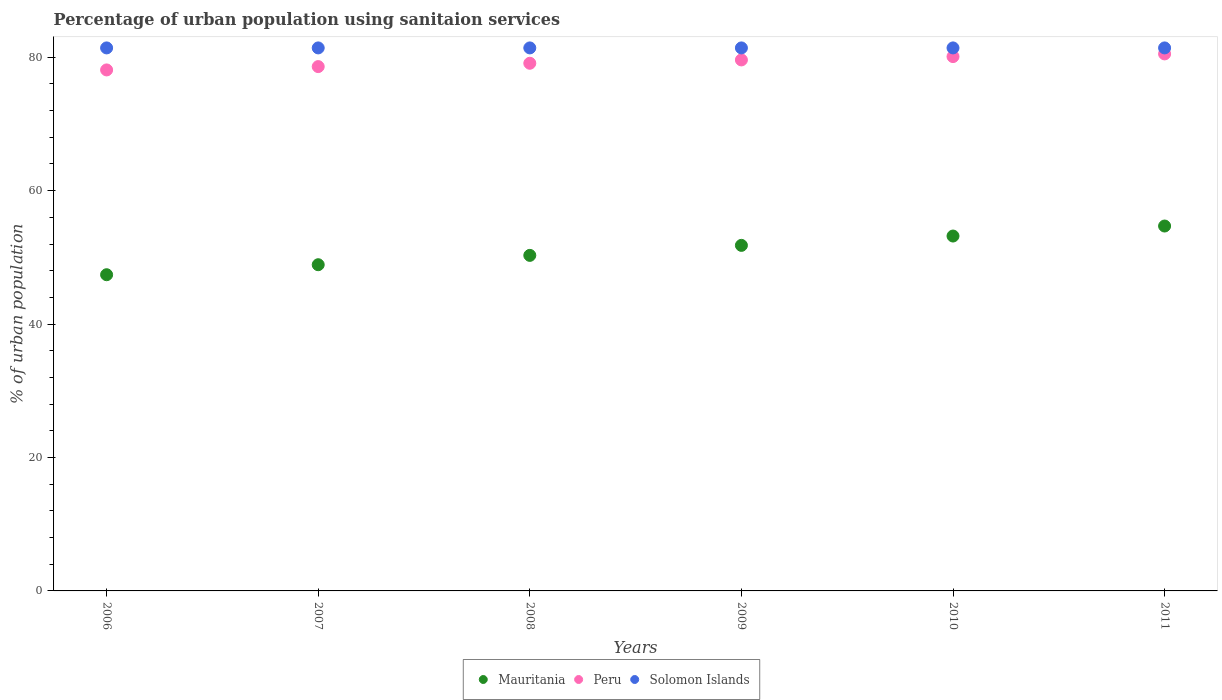Is the number of dotlines equal to the number of legend labels?
Your response must be concise. Yes. What is the percentage of urban population using sanitaion services in Mauritania in 2011?
Your response must be concise. 54.7. Across all years, what is the maximum percentage of urban population using sanitaion services in Mauritania?
Offer a very short reply. 54.7. Across all years, what is the minimum percentage of urban population using sanitaion services in Solomon Islands?
Give a very brief answer. 81.4. In which year was the percentage of urban population using sanitaion services in Mauritania minimum?
Your response must be concise. 2006. What is the total percentage of urban population using sanitaion services in Mauritania in the graph?
Provide a short and direct response. 306.3. What is the difference between the percentage of urban population using sanitaion services in Solomon Islands in 2008 and that in 2010?
Your answer should be very brief. 0. What is the difference between the percentage of urban population using sanitaion services in Solomon Islands in 2009 and the percentage of urban population using sanitaion services in Peru in 2008?
Your response must be concise. 2.3. What is the average percentage of urban population using sanitaion services in Peru per year?
Your answer should be very brief. 79.33. In the year 2010, what is the difference between the percentage of urban population using sanitaion services in Mauritania and percentage of urban population using sanitaion services in Solomon Islands?
Your answer should be compact. -28.2. Is the percentage of urban population using sanitaion services in Peru in 2008 less than that in 2010?
Keep it short and to the point. Yes. Is the difference between the percentage of urban population using sanitaion services in Mauritania in 2006 and 2008 greater than the difference between the percentage of urban population using sanitaion services in Solomon Islands in 2006 and 2008?
Your answer should be compact. No. What is the difference between the highest and the second highest percentage of urban population using sanitaion services in Mauritania?
Keep it short and to the point. 1.5. What is the difference between the highest and the lowest percentage of urban population using sanitaion services in Peru?
Your response must be concise. 2.4. Is the sum of the percentage of urban population using sanitaion services in Peru in 2006 and 2011 greater than the maximum percentage of urban population using sanitaion services in Mauritania across all years?
Provide a succinct answer. Yes. Is the percentage of urban population using sanitaion services in Solomon Islands strictly less than the percentage of urban population using sanitaion services in Peru over the years?
Your answer should be very brief. No. Are the values on the major ticks of Y-axis written in scientific E-notation?
Give a very brief answer. No. Does the graph contain grids?
Give a very brief answer. No. What is the title of the graph?
Keep it short and to the point. Percentage of urban population using sanitaion services. What is the label or title of the Y-axis?
Your answer should be very brief. % of urban population. What is the % of urban population of Mauritania in 2006?
Provide a short and direct response. 47.4. What is the % of urban population of Peru in 2006?
Ensure brevity in your answer.  78.1. What is the % of urban population of Solomon Islands in 2006?
Provide a succinct answer. 81.4. What is the % of urban population of Mauritania in 2007?
Your answer should be very brief. 48.9. What is the % of urban population in Peru in 2007?
Offer a terse response. 78.6. What is the % of urban population in Solomon Islands in 2007?
Give a very brief answer. 81.4. What is the % of urban population in Mauritania in 2008?
Your answer should be compact. 50.3. What is the % of urban population of Peru in 2008?
Your response must be concise. 79.1. What is the % of urban population in Solomon Islands in 2008?
Keep it short and to the point. 81.4. What is the % of urban population of Mauritania in 2009?
Provide a succinct answer. 51.8. What is the % of urban population of Peru in 2009?
Ensure brevity in your answer.  79.6. What is the % of urban population of Solomon Islands in 2009?
Keep it short and to the point. 81.4. What is the % of urban population in Mauritania in 2010?
Your response must be concise. 53.2. What is the % of urban population in Peru in 2010?
Offer a terse response. 80.1. What is the % of urban population of Solomon Islands in 2010?
Your response must be concise. 81.4. What is the % of urban population in Mauritania in 2011?
Offer a very short reply. 54.7. What is the % of urban population in Peru in 2011?
Ensure brevity in your answer.  80.5. What is the % of urban population of Solomon Islands in 2011?
Provide a short and direct response. 81.4. Across all years, what is the maximum % of urban population of Mauritania?
Your answer should be very brief. 54.7. Across all years, what is the maximum % of urban population in Peru?
Make the answer very short. 80.5. Across all years, what is the maximum % of urban population of Solomon Islands?
Your answer should be very brief. 81.4. Across all years, what is the minimum % of urban population in Mauritania?
Make the answer very short. 47.4. Across all years, what is the minimum % of urban population in Peru?
Give a very brief answer. 78.1. Across all years, what is the minimum % of urban population in Solomon Islands?
Give a very brief answer. 81.4. What is the total % of urban population of Mauritania in the graph?
Provide a short and direct response. 306.3. What is the total % of urban population of Peru in the graph?
Make the answer very short. 476. What is the total % of urban population in Solomon Islands in the graph?
Keep it short and to the point. 488.4. What is the difference between the % of urban population in Mauritania in 2006 and that in 2007?
Make the answer very short. -1.5. What is the difference between the % of urban population in Peru in 2006 and that in 2007?
Your response must be concise. -0.5. What is the difference between the % of urban population in Solomon Islands in 2006 and that in 2008?
Keep it short and to the point. 0. What is the difference between the % of urban population in Peru in 2006 and that in 2009?
Ensure brevity in your answer.  -1.5. What is the difference between the % of urban population in Solomon Islands in 2006 and that in 2009?
Your answer should be compact. 0. What is the difference between the % of urban population in Mauritania in 2006 and that in 2011?
Give a very brief answer. -7.3. What is the difference between the % of urban population in Solomon Islands in 2006 and that in 2011?
Offer a very short reply. 0. What is the difference between the % of urban population in Mauritania in 2007 and that in 2008?
Your answer should be very brief. -1.4. What is the difference between the % of urban population of Peru in 2007 and that in 2008?
Provide a succinct answer. -0.5. What is the difference between the % of urban population in Mauritania in 2007 and that in 2009?
Ensure brevity in your answer.  -2.9. What is the difference between the % of urban population of Peru in 2007 and that in 2009?
Ensure brevity in your answer.  -1. What is the difference between the % of urban population in Peru in 2007 and that in 2010?
Provide a short and direct response. -1.5. What is the difference between the % of urban population in Mauritania in 2007 and that in 2011?
Your response must be concise. -5.8. What is the difference between the % of urban population of Solomon Islands in 2007 and that in 2011?
Offer a terse response. 0. What is the difference between the % of urban population in Peru in 2008 and that in 2009?
Offer a terse response. -0.5. What is the difference between the % of urban population in Mauritania in 2008 and that in 2010?
Offer a terse response. -2.9. What is the difference between the % of urban population of Peru in 2008 and that in 2010?
Give a very brief answer. -1. What is the difference between the % of urban population of Solomon Islands in 2008 and that in 2010?
Make the answer very short. 0. What is the difference between the % of urban population of Solomon Islands in 2008 and that in 2011?
Offer a terse response. 0. What is the difference between the % of urban population of Peru in 2009 and that in 2010?
Offer a very short reply. -0.5. What is the difference between the % of urban population of Solomon Islands in 2009 and that in 2010?
Make the answer very short. 0. What is the difference between the % of urban population in Peru in 2009 and that in 2011?
Your answer should be very brief. -0.9. What is the difference between the % of urban population in Mauritania in 2006 and the % of urban population in Peru in 2007?
Your response must be concise. -31.2. What is the difference between the % of urban population of Mauritania in 2006 and the % of urban population of Solomon Islands in 2007?
Your answer should be very brief. -34. What is the difference between the % of urban population of Peru in 2006 and the % of urban population of Solomon Islands in 2007?
Offer a very short reply. -3.3. What is the difference between the % of urban population in Mauritania in 2006 and the % of urban population in Peru in 2008?
Your answer should be very brief. -31.7. What is the difference between the % of urban population in Mauritania in 2006 and the % of urban population in Solomon Islands in 2008?
Provide a succinct answer. -34. What is the difference between the % of urban population in Peru in 2006 and the % of urban population in Solomon Islands in 2008?
Provide a succinct answer. -3.3. What is the difference between the % of urban population of Mauritania in 2006 and the % of urban population of Peru in 2009?
Offer a terse response. -32.2. What is the difference between the % of urban population of Mauritania in 2006 and the % of urban population of Solomon Islands in 2009?
Provide a short and direct response. -34. What is the difference between the % of urban population in Mauritania in 2006 and the % of urban population in Peru in 2010?
Offer a terse response. -32.7. What is the difference between the % of urban population of Mauritania in 2006 and the % of urban population of Solomon Islands in 2010?
Your answer should be compact. -34. What is the difference between the % of urban population in Mauritania in 2006 and the % of urban population in Peru in 2011?
Your response must be concise. -33.1. What is the difference between the % of urban population of Mauritania in 2006 and the % of urban population of Solomon Islands in 2011?
Your answer should be compact. -34. What is the difference between the % of urban population in Peru in 2006 and the % of urban population in Solomon Islands in 2011?
Keep it short and to the point. -3.3. What is the difference between the % of urban population of Mauritania in 2007 and the % of urban population of Peru in 2008?
Provide a succinct answer. -30.2. What is the difference between the % of urban population in Mauritania in 2007 and the % of urban population in Solomon Islands in 2008?
Provide a succinct answer. -32.5. What is the difference between the % of urban population in Mauritania in 2007 and the % of urban population in Peru in 2009?
Your answer should be very brief. -30.7. What is the difference between the % of urban population of Mauritania in 2007 and the % of urban population of Solomon Islands in 2009?
Ensure brevity in your answer.  -32.5. What is the difference between the % of urban population of Mauritania in 2007 and the % of urban population of Peru in 2010?
Provide a succinct answer. -31.2. What is the difference between the % of urban population in Mauritania in 2007 and the % of urban population in Solomon Islands in 2010?
Your answer should be compact. -32.5. What is the difference between the % of urban population of Mauritania in 2007 and the % of urban population of Peru in 2011?
Make the answer very short. -31.6. What is the difference between the % of urban population of Mauritania in 2007 and the % of urban population of Solomon Islands in 2011?
Give a very brief answer. -32.5. What is the difference between the % of urban population of Mauritania in 2008 and the % of urban population of Peru in 2009?
Make the answer very short. -29.3. What is the difference between the % of urban population of Mauritania in 2008 and the % of urban population of Solomon Islands in 2009?
Your response must be concise. -31.1. What is the difference between the % of urban population of Peru in 2008 and the % of urban population of Solomon Islands in 2009?
Provide a short and direct response. -2.3. What is the difference between the % of urban population of Mauritania in 2008 and the % of urban population of Peru in 2010?
Keep it short and to the point. -29.8. What is the difference between the % of urban population of Mauritania in 2008 and the % of urban population of Solomon Islands in 2010?
Your response must be concise. -31.1. What is the difference between the % of urban population of Mauritania in 2008 and the % of urban population of Peru in 2011?
Ensure brevity in your answer.  -30.2. What is the difference between the % of urban population in Mauritania in 2008 and the % of urban population in Solomon Islands in 2011?
Keep it short and to the point. -31.1. What is the difference between the % of urban population in Peru in 2008 and the % of urban population in Solomon Islands in 2011?
Provide a succinct answer. -2.3. What is the difference between the % of urban population of Mauritania in 2009 and the % of urban population of Peru in 2010?
Your response must be concise. -28.3. What is the difference between the % of urban population in Mauritania in 2009 and the % of urban population in Solomon Islands in 2010?
Your response must be concise. -29.6. What is the difference between the % of urban population of Peru in 2009 and the % of urban population of Solomon Islands in 2010?
Your answer should be compact. -1.8. What is the difference between the % of urban population of Mauritania in 2009 and the % of urban population of Peru in 2011?
Your answer should be compact. -28.7. What is the difference between the % of urban population of Mauritania in 2009 and the % of urban population of Solomon Islands in 2011?
Offer a very short reply. -29.6. What is the difference between the % of urban population of Peru in 2009 and the % of urban population of Solomon Islands in 2011?
Ensure brevity in your answer.  -1.8. What is the difference between the % of urban population of Mauritania in 2010 and the % of urban population of Peru in 2011?
Offer a very short reply. -27.3. What is the difference between the % of urban population of Mauritania in 2010 and the % of urban population of Solomon Islands in 2011?
Offer a terse response. -28.2. What is the average % of urban population of Mauritania per year?
Provide a succinct answer. 51.05. What is the average % of urban population in Peru per year?
Your response must be concise. 79.33. What is the average % of urban population of Solomon Islands per year?
Give a very brief answer. 81.4. In the year 2006, what is the difference between the % of urban population in Mauritania and % of urban population in Peru?
Give a very brief answer. -30.7. In the year 2006, what is the difference between the % of urban population in Mauritania and % of urban population in Solomon Islands?
Your response must be concise. -34. In the year 2006, what is the difference between the % of urban population in Peru and % of urban population in Solomon Islands?
Provide a succinct answer. -3.3. In the year 2007, what is the difference between the % of urban population in Mauritania and % of urban population in Peru?
Offer a terse response. -29.7. In the year 2007, what is the difference between the % of urban population in Mauritania and % of urban population in Solomon Islands?
Your answer should be compact. -32.5. In the year 2008, what is the difference between the % of urban population of Mauritania and % of urban population of Peru?
Provide a succinct answer. -28.8. In the year 2008, what is the difference between the % of urban population in Mauritania and % of urban population in Solomon Islands?
Ensure brevity in your answer.  -31.1. In the year 2008, what is the difference between the % of urban population in Peru and % of urban population in Solomon Islands?
Your answer should be very brief. -2.3. In the year 2009, what is the difference between the % of urban population in Mauritania and % of urban population in Peru?
Offer a very short reply. -27.8. In the year 2009, what is the difference between the % of urban population in Mauritania and % of urban population in Solomon Islands?
Make the answer very short. -29.6. In the year 2009, what is the difference between the % of urban population in Peru and % of urban population in Solomon Islands?
Give a very brief answer. -1.8. In the year 2010, what is the difference between the % of urban population in Mauritania and % of urban population in Peru?
Your answer should be compact. -26.9. In the year 2010, what is the difference between the % of urban population in Mauritania and % of urban population in Solomon Islands?
Offer a very short reply. -28.2. In the year 2011, what is the difference between the % of urban population of Mauritania and % of urban population of Peru?
Make the answer very short. -25.8. In the year 2011, what is the difference between the % of urban population of Mauritania and % of urban population of Solomon Islands?
Offer a terse response. -26.7. In the year 2011, what is the difference between the % of urban population of Peru and % of urban population of Solomon Islands?
Your answer should be compact. -0.9. What is the ratio of the % of urban population in Mauritania in 2006 to that in 2007?
Your response must be concise. 0.97. What is the ratio of the % of urban population of Peru in 2006 to that in 2007?
Offer a terse response. 0.99. What is the ratio of the % of urban population of Mauritania in 2006 to that in 2008?
Give a very brief answer. 0.94. What is the ratio of the % of urban population of Peru in 2006 to that in 2008?
Keep it short and to the point. 0.99. What is the ratio of the % of urban population of Mauritania in 2006 to that in 2009?
Make the answer very short. 0.92. What is the ratio of the % of urban population of Peru in 2006 to that in 2009?
Your response must be concise. 0.98. What is the ratio of the % of urban population of Mauritania in 2006 to that in 2010?
Your response must be concise. 0.89. What is the ratio of the % of urban population in Peru in 2006 to that in 2010?
Your answer should be compact. 0.97. What is the ratio of the % of urban population in Solomon Islands in 2006 to that in 2010?
Ensure brevity in your answer.  1. What is the ratio of the % of urban population of Mauritania in 2006 to that in 2011?
Provide a short and direct response. 0.87. What is the ratio of the % of urban population in Peru in 2006 to that in 2011?
Make the answer very short. 0.97. What is the ratio of the % of urban population of Mauritania in 2007 to that in 2008?
Make the answer very short. 0.97. What is the ratio of the % of urban population of Peru in 2007 to that in 2008?
Your answer should be compact. 0.99. What is the ratio of the % of urban population of Mauritania in 2007 to that in 2009?
Provide a succinct answer. 0.94. What is the ratio of the % of urban population in Peru in 2007 to that in 2009?
Make the answer very short. 0.99. What is the ratio of the % of urban population of Mauritania in 2007 to that in 2010?
Your response must be concise. 0.92. What is the ratio of the % of urban population of Peru in 2007 to that in 2010?
Make the answer very short. 0.98. What is the ratio of the % of urban population of Mauritania in 2007 to that in 2011?
Provide a short and direct response. 0.89. What is the ratio of the % of urban population of Peru in 2007 to that in 2011?
Provide a succinct answer. 0.98. What is the ratio of the % of urban population in Mauritania in 2008 to that in 2009?
Your answer should be very brief. 0.97. What is the ratio of the % of urban population of Peru in 2008 to that in 2009?
Your answer should be very brief. 0.99. What is the ratio of the % of urban population in Mauritania in 2008 to that in 2010?
Your response must be concise. 0.95. What is the ratio of the % of urban population of Peru in 2008 to that in 2010?
Make the answer very short. 0.99. What is the ratio of the % of urban population in Mauritania in 2008 to that in 2011?
Your answer should be compact. 0.92. What is the ratio of the % of urban population of Peru in 2008 to that in 2011?
Offer a very short reply. 0.98. What is the ratio of the % of urban population of Solomon Islands in 2008 to that in 2011?
Keep it short and to the point. 1. What is the ratio of the % of urban population of Mauritania in 2009 to that in 2010?
Your answer should be compact. 0.97. What is the ratio of the % of urban population of Mauritania in 2009 to that in 2011?
Ensure brevity in your answer.  0.95. What is the ratio of the % of urban population in Mauritania in 2010 to that in 2011?
Ensure brevity in your answer.  0.97. What is the ratio of the % of urban population in Solomon Islands in 2010 to that in 2011?
Provide a short and direct response. 1. What is the difference between the highest and the second highest % of urban population of Mauritania?
Offer a terse response. 1.5. What is the difference between the highest and the second highest % of urban population of Peru?
Keep it short and to the point. 0.4. What is the difference between the highest and the lowest % of urban population in Peru?
Make the answer very short. 2.4. 